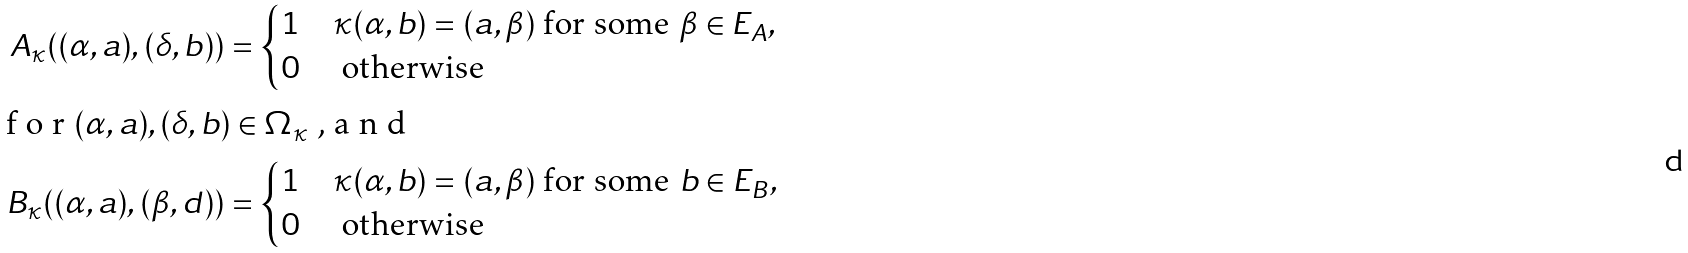Convert formula to latex. <formula><loc_0><loc_0><loc_500><loc_500>A _ { \kappa } ( ( \alpha , a ) , ( \delta , b ) ) & = { \begin{cases} 1 & \kappa ( \alpha , b ) = ( a , \beta ) \text { for some } \beta \in E _ { A } , \\ 0 & \text { otherwise} \end{cases} } \\ \intertext { f o r $ ( \alpha , a ) , ( \delta , b ) \in \Omega _ { \kappa } $ , a n d } B _ { \kappa } ( ( \alpha , a ) , ( \beta , d ) ) & = { \begin{cases} 1 & \kappa ( \alpha , b ) = ( a , \beta ) \text { for some } b \in E _ { B } , \\ 0 & \text { otherwise} \end{cases} }</formula> 